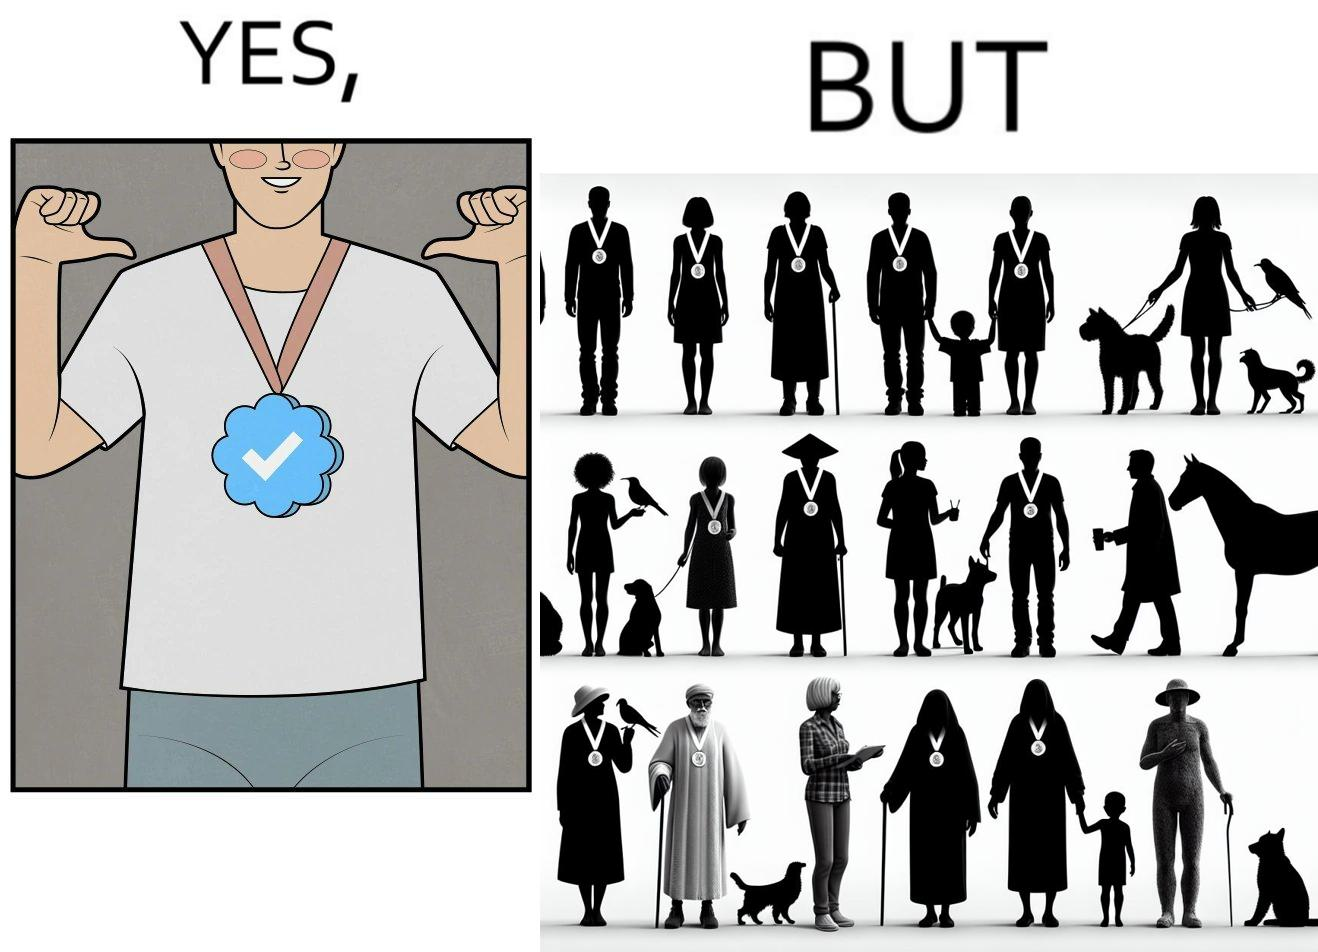Is this image satirical or non-satirical? Yes, this image is satirical. 